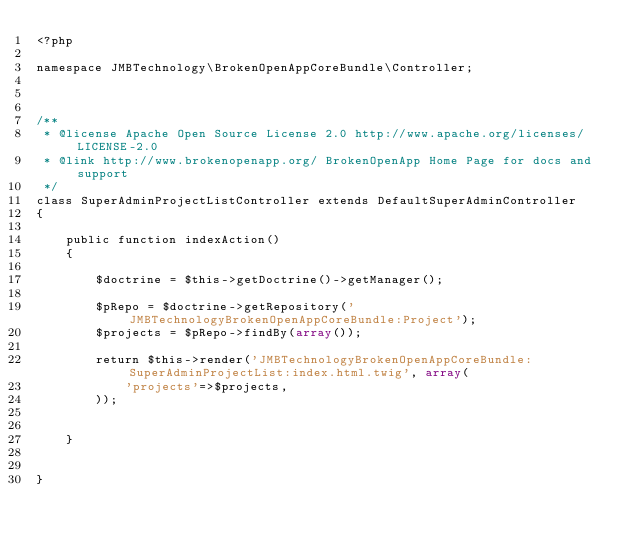Convert code to text. <code><loc_0><loc_0><loc_500><loc_500><_PHP_><?php

namespace JMBTechnology\BrokenOpenAppCoreBundle\Controller;



/**
 * @license Apache Open Source License 2.0 http://www.apache.org/licenses/LICENSE-2.0
 * @link http://www.brokenopenapp.org/ BrokenOpenApp Home Page for docs and support
 */
class SuperAdminProjectListController extends DefaultSuperAdminController
{

	public function indexAction()
	{

		$doctrine = $this->getDoctrine()->getManager();

		$pRepo = $doctrine->getRepository('JMBTechnologyBrokenOpenAppCoreBundle:Project');
		$projects = $pRepo->findBy(array());

		return $this->render('JMBTechnologyBrokenOpenAppCoreBundle:SuperAdminProjectList:index.html.twig', array(
			'projects'=>$projects,
		));


	}


}
</code> 